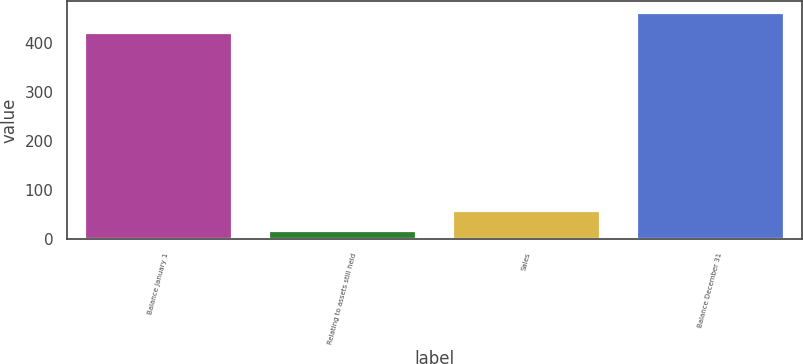Convert chart. <chart><loc_0><loc_0><loc_500><loc_500><bar_chart><fcel>Balance January 1<fcel>Relating to assets still held<fcel>Sales<fcel>Balance December 31<nl><fcel>420<fcel>16<fcel>57.2<fcel>461.2<nl></chart> 